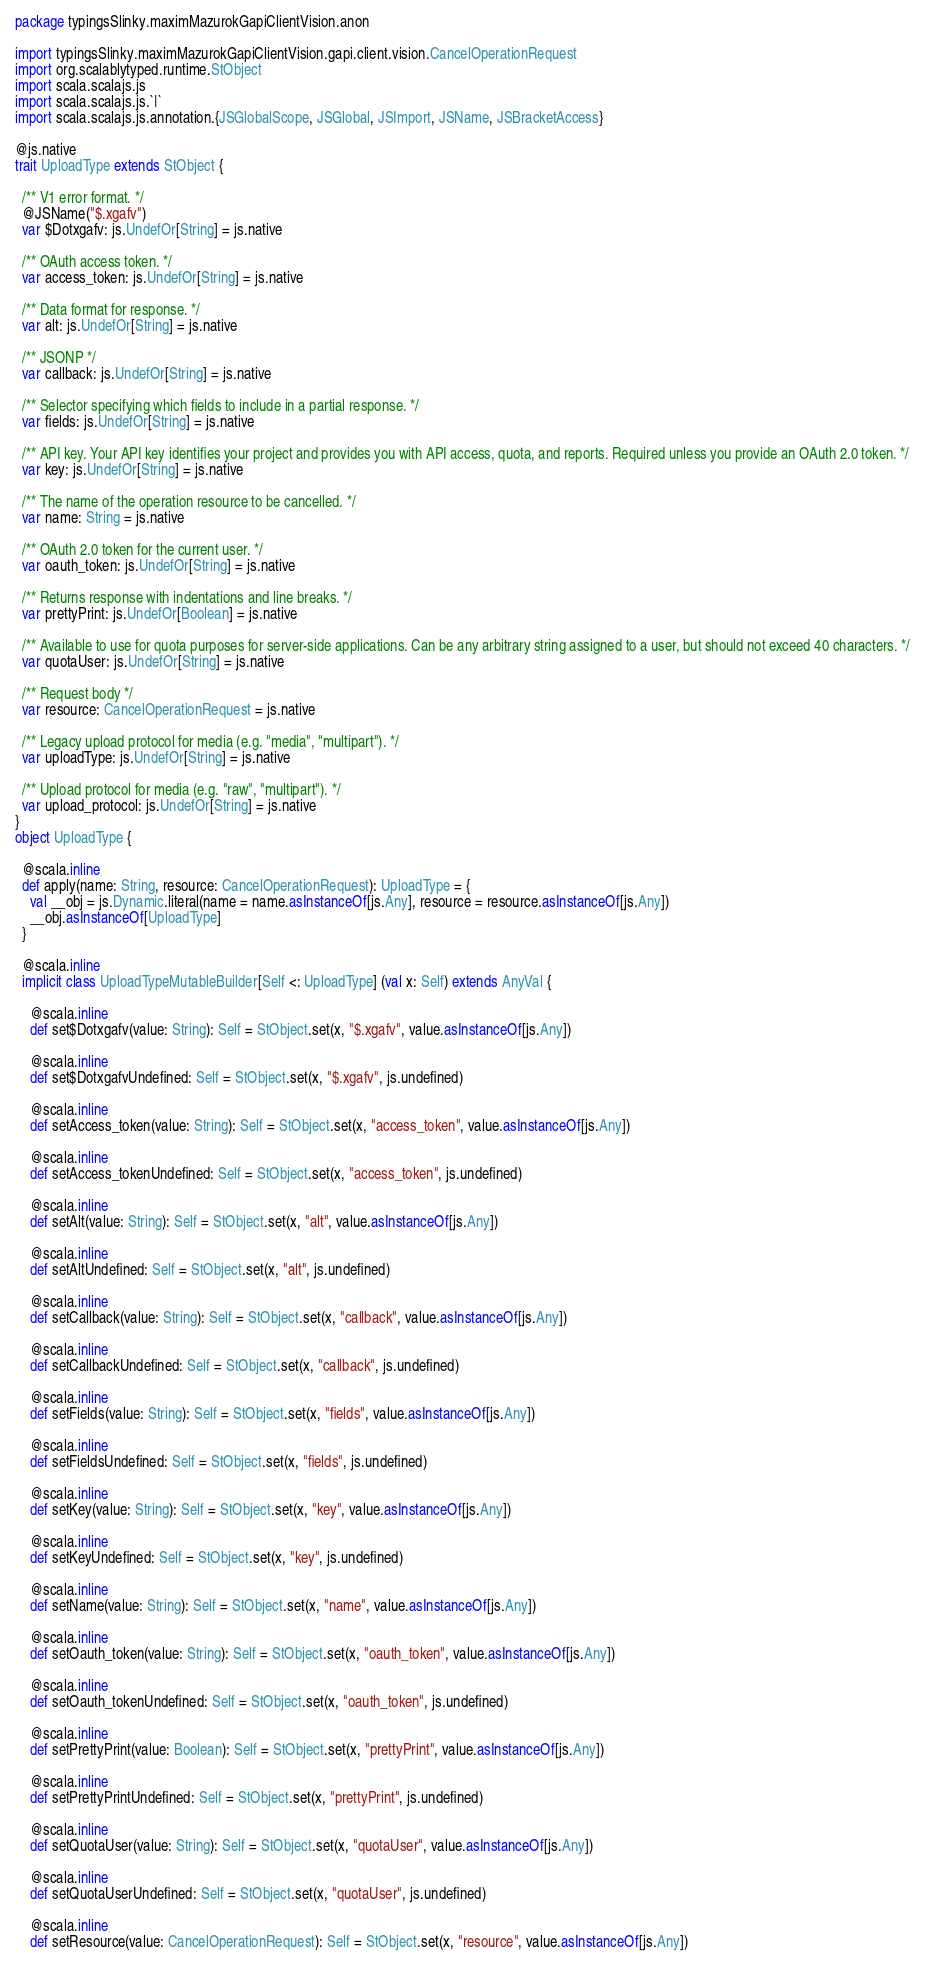<code> <loc_0><loc_0><loc_500><loc_500><_Scala_>package typingsSlinky.maximMazurokGapiClientVision.anon

import typingsSlinky.maximMazurokGapiClientVision.gapi.client.vision.CancelOperationRequest
import org.scalablytyped.runtime.StObject
import scala.scalajs.js
import scala.scalajs.js.`|`
import scala.scalajs.js.annotation.{JSGlobalScope, JSGlobal, JSImport, JSName, JSBracketAccess}

@js.native
trait UploadType extends StObject {
  
  /** V1 error format. */
  @JSName("$.xgafv")
  var $Dotxgafv: js.UndefOr[String] = js.native
  
  /** OAuth access token. */
  var access_token: js.UndefOr[String] = js.native
  
  /** Data format for response. */
  var alt: js.UndefOr[String] = js.native
  
  /** JSONP */
  var callback: js.UndefOr[String] = js.native
  
  /** Selector specifying which fields to include in a partial response. */
  var fields: js.UndefOr[String] = js.native
  
  /** API key. Your API key identifies your project and provides you with API access, quota, and reports. Required unless you provide an OAuth 2.0 token. */
  var key: js.UndefOr[String] = js.native
  
  /** The name of the operation resource to be cancelled. */
  var name: String = js.native
  
  /** OAuth 2.0 token for the current user. */
  var oauth_token: js.UndefOr[String] = js.native
  
  /** Returns response with indentations and line breaks. */
  var prettyPrint: js.UndefOr[Boolean] = js.native
  
  /** Available to use for quota purposes for server-side applications. Can be any arbitrary string assigned to a user, but should not exceed 40 characters. */
  var quotaUser: js.UndefOr[String] = js.native
  
  /** Request body */
  var resource: CancelOperationRequest = js.native
  
  /** Legacy upload protocol for media (e.g. "media", "multipart"). */
  var uploadType: js.UndefOr[String] = js.native
  
  /** Upload protocol for media (e.g. "raw", "multipart"). */
  var upload_protocol: js.UndefOr[String] = js.native
}
object UploadType {
  
  @scala.inline
  def apply(name: String, resource: CancelOperationRequest): UploadType = {
    val __obj = js.Dynamic.literal(name = name.asInstanceOf[js.Any], resource = resource.asInstanceOf[js.Any])
    __obj.asInstanceOf[UploadType]
  }
  
  @scala.inline
  implicit class UploadTypeMutableBuilder[Self <: UploadType] (val x: Self) extends AnyVal {
    
    @scala.inline
    def set$Dotxgafv(value: String): Self = StObject.set(x, "$.xgafv", value.asInstanceOf[js.Any])
    
    @scala.inline
    def set$DotxgafvUndefined: Self = StObject.set(x, "$.xgafv", js.undefined)
    
    @scala.inline
    def setAccess_token(value: String): Self = StObject.set(x, "access_token", value.asInstanceOf[js.Any])
    
    @scala.inline
    def setAccess_tokenUndefined: Self = StObject.set(x, "access_token", js.undefined)
    
    @scala.inline
    def setAlt(value: String): Self = StObject.set(x, "alt", value.asInstanceOf[js.Any])
    
    @scala.inline
    def setAltUndefined: Self = StObject.set(x, "alt", js.undefined)
    
    @scala.inline
    def setCallback(value: String): Self = StObject.set(x, "callback", value.asInstanceOf[js.Any])
    
    @scala.inline
    def setCallbackUndefined: Self = StObject.set(x, "callback", js.undefined)
    
    @scala.inline
    def setFields(value: String): Self = StObject.set(x, "fields", value.asInstanceOf[js.Any])
    
    @scala.inline
    def setFieldsUndefined: Self = StObject.set(x, "fields", js.undefined)
    
    @scala.inline
    def setKey(value: String): Self = StObject.set(x, "key", value.asInstanceOf[js.Any])
    
    @scala.inline
    def setKeyUndefined: Self = StObject.set(x, "key", js.undefined)
    
    @scala.inline
    def setName(value: String): Self = StObject.set(x, "name", value.asInstanceOf[js.Any])
    
    @scala.inline
    def setOauth_token(value: String): Self = StObject.set(x, "oauth_token", value.asInstanceOf[js.Any])
    
    @scala.inline
    def setOauth_tokenUndefined: Self = StObject.set(x, "oauth_token", js.undefined)
    
    @scala.inline
    def setPrettyPrint(value: Boolean): Self = StObject.set(x, "prettyPrint", value.asInstanceOf[js.Any])
    
    @scala.inline
    def setPrettyPrintUndefined: Self = StObject.set(x, "prettyPrint", js.undefined)
    
    @scala.inline
    def setQuotaUser(value: String): Self = StObject.set(x, "quotaUser", value.asInstanceOf[js.Any])
    
    @scala.inline
    def setQuotaUserUndefined: Self = StObject.set(x, "quotaUser", js.undefined)
    
    @scala.inline
    def setResource(value: CancelOperationRequest): Self = StObject.set(x, "resource", value.asInstanceOf[js.Any])
    </code> 